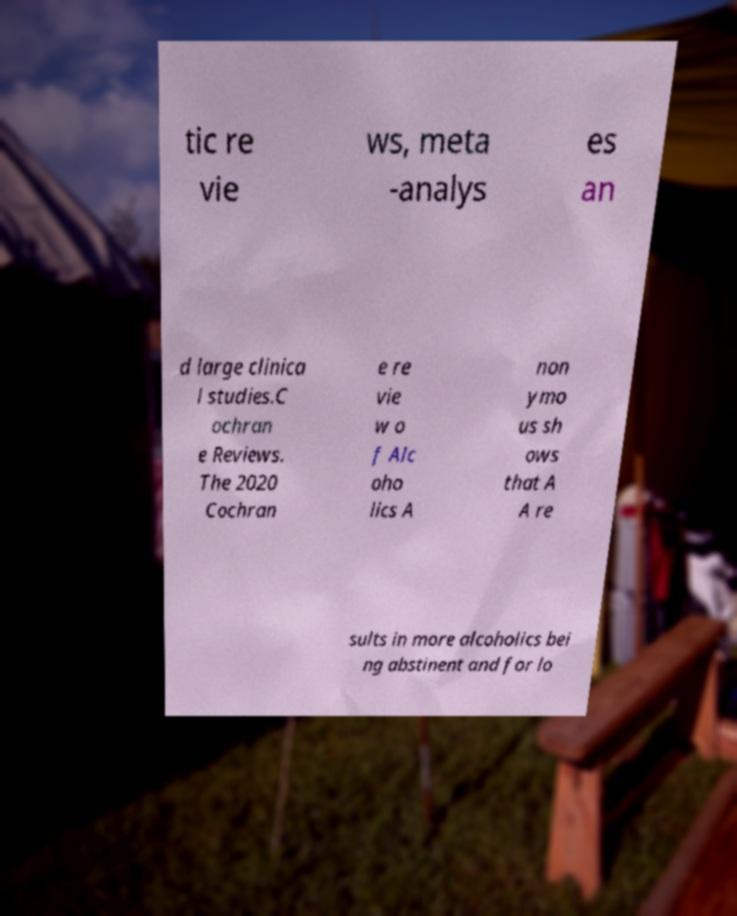Please read and relay the text visible in this image. What does it say? tic re vie ws, meta -analys es an d large clinica l studies.C ochran e Reviews. The 2020 Cochran e re vie w o f Alc oho lics A non ymo us sh ows that A A re sults in more alcoholics bei ng abstinent and for lo 